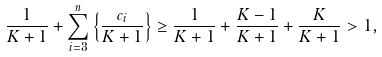Convert formula to latex. <formula><loc_0><loc_0><loc_500><loc_500>\frac { 1 } { K + 1 } + \sum _ { i = 3 } ^ { n } \left \{ \frac { c _ { i } } { K + 1 } \right \} \geq \frac { 1 } { K + 1 } + \frac { K - 1 } { K + 1 } + \frac { K } { K + 1 } > 1 ,</formula> 